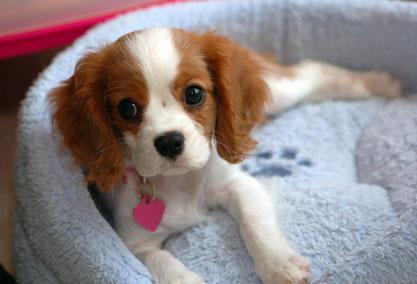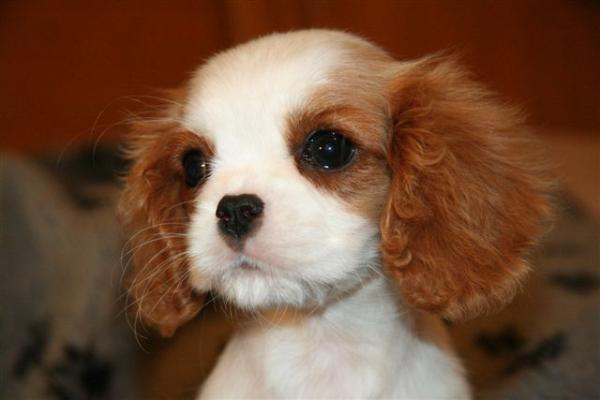The first image is the image on the left, the second image is the image on the right. For the images shown, is this caption "There are no more than two puppies." true? Answer yes or no. Yes. The first image is the image on the left, the second image is the image on the right. Considering the images on both sides, is "There are at most 2 puppies." valid? Answer yes or no. Yes. The first image is the image on the left, the second image is the image on the right. Examine the images to the left and right. Is the description "There are atleast 4 cute dogs total" accurate? Answer yes or no. No. The first image is the image on the left, the second image is the image on the right. Assess this claim about the two images: "There are at most two dogs.". Correct or not? Answer yes or no. Yes. 